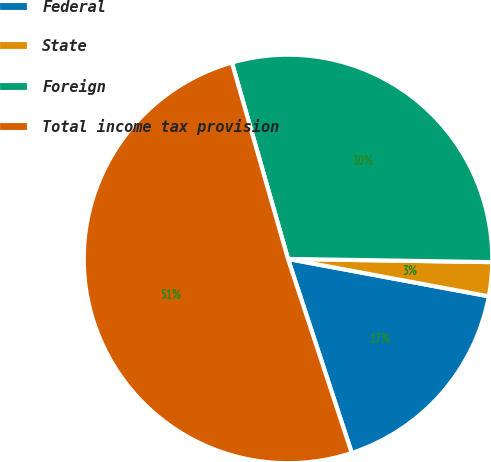Convert chart. <chart><loc_0><loc_0><loc_500><loc_500><pie_chart><fcel>Federal<fcel>State<fcel>Foreign<fcel>Total income tax provision<nl><fcel>17.02%<fcel>2.68%<fcel>29.68%<fcel>50.62%<nl></chart> 